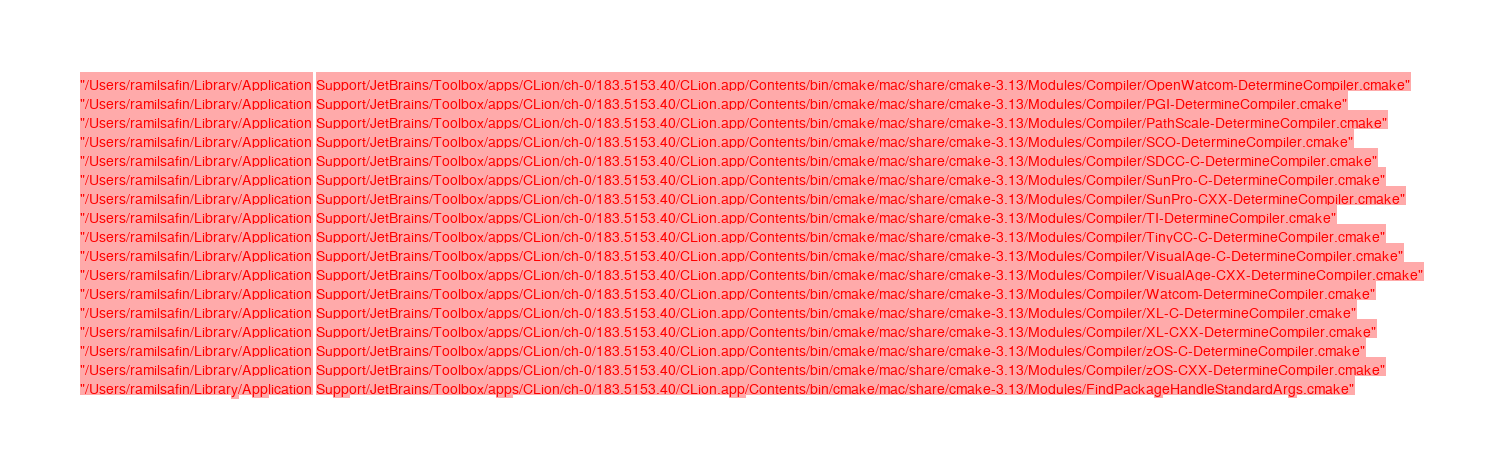Convert code to text. <code><loc_0><loc_0><loc_500><loc_500><_CMake_>  "/Users/ramilsafin/Library/Application Support/JetBrains/Toolbox/apps/CLion/ch-0/183.5153.40/CLion.app/Contents/bin/cmake/mac/share/cmake-3.13/Modules/Compiler/OpenWatcom-DetermineCompiler.cmake"
  "/Users/ramilsafin/Library/Application Support/JetBrains/Toolbox/apps/CLion/ch-0/183.5153.40/CLion.app/Contents/bin/cmake/mac/share/cmake-3.13/Modules/Compiler/PGI-DetermineCompiler.cmake"
  "/Users/ramilsafin/Library/Application Support/JetBrains/Toolbox/apps/CLion/ch-0/183.5153.40/CLion.app/Contents/bin/cmake/mac/share/cmake-3.13/Modules/Compiler/PathScale-DetermineCompiler.cmake"
  "/Users/ramilsafin/Library/Application Support/JetBrains/Toolbox/apps/CLion/ch-0/183.5153.40/CLion.app/Contents/bin/cmake/mac/share/cmake-3.13/Modules/Compiler/SCO-DetermineCompiler.cmake"
  "/Users/ramilsafin/Library/Application Support/JetBrains/Toolbox/apps/CLion/ch-0/183.5153.40/CLion.app/Contents/bin/cmake/mac/share/cmake-3.13/Modules/Compiler/SDCC-C-DetermineCompiler.cmake"
  "/Users/ramilsafin/Library/Application Support/JetBrains/Toolbox/apps/CLion/ch-0/183.5153.40/CLion.app/Contents/bin/cmake/mac/share/cmake-3.13/Modules/Compiler/SunPro-C-DetermineCompiler.cmake"
  "/Users/ramilsafin/Library/Application Support/JetBrains/Toolbox/apps/CLion/ch-0/183.5153.40/CLion.app/Contents/bin/cmake/mac/share/cmake-3.13/Modules/Compiler/SunPro-CXX-DetermineCompiler.cmake"
  "/Users/ramilsafin/Library/Application Support/JetBrains/Toolbox/apps/CLion/ch-0/183.5153.40/CLion.app/Contents/bin/cmake/mac/share/cmake-3.13/Modules/Compiler/TI-DetermineCompiler.cmake"
  "/Users/ramilsafin/Library/Application Support/JetBrains/Toolbox/apps/CLion/ch-0/183.5153.40/CLion.app/Contents/bin/cmake/mac/share/cmake-3.13/Modules/Compiler/TinyCC-C-DetermineCompiler.cmake"
  "/Users/ramilsafin/Library/Application Support/JetBrains/Toolbox/apps/CLion/ch-0/183.5153.40/CLion.app/Contents/bin/cmake/mac/share/cmake-3.13/Modules/Compiler/VisualAge-C-DetermineCompiler.cmake"
  "/Users/ramilsafin/Library/Application Support/JetBrains/Toolbox/apps/CLion/ch-0/183.5153.40/CLion.app/Contents/bin/cmake/mac/share/cmake-3.13/Modules/Compiler/VisualAge-CXX-DetermineCompiler.cmake"
  "/Users/ramilsafin/Library/Application Support/JetBrains/Toolbox/apps/CLion/ch-0/183.5153.40/CLion.app/Contents/bin/cmake/mac/share/cmake-3.13/Modules/Compiler/Watcom-DetermineCompiler.cmake"
  "/Users/ramilsafin/Library/Application Support/JetBrains/Toolbox/apps/CLion/ch-0/183.5153.40/CLion.app/Contents/bin/cmake/mac/share/cmake-3.13/Modules/Compiler/XL-C-DetermineCompiler.cmake"
  "/Users/ramilsafin/Library/Application Support/JetBrains/Toolbox/apps/CLion/ch-0/183.5153.40/CLion.app/Contents/bin/cmake/mac/share/cmake-3.13/Modules/Compiler/XL-CXX-DetermineCompiler.cmake"
  "/Users/ramilsafin/Library/Application Support/JetBrains/Toolbox/apps/CLion/ch-0/183.5153.40/CLion.app/Contents/bin/cmake/mac/share/cmake-3.13/Modules/Compiler/zOS-C-DetermineCompiler.cmake"
  "/Users/ramilsafin/Library/Application Support/JetBrains/Toolbox/apps/CLion/ch-0/183.5153.40/CLion.app/Contents/bin/cmake/mac/share/cmake-3.13/Modules/Compiler/zOS-CXX-DetermineCompiler.cmake"
  "/Users/ramilsafin/Library/Application Support/JetBrains/Toolbox/apps/CLion/ch-0/183.5153.40/CLion.app/Contents/bin/cmake/mac/share/cmake-3.13/Modules/FindPackageHandleStandardArgs.cmake"</code> 